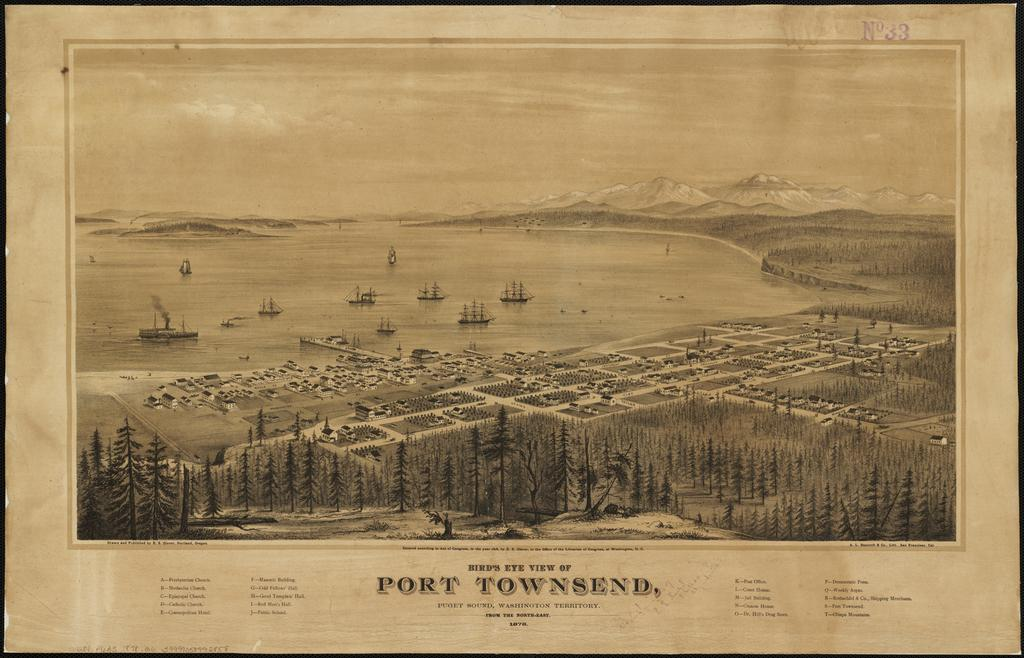Provide a one-sentence caption for the provided image. an old print of the town of Port Townsend. 